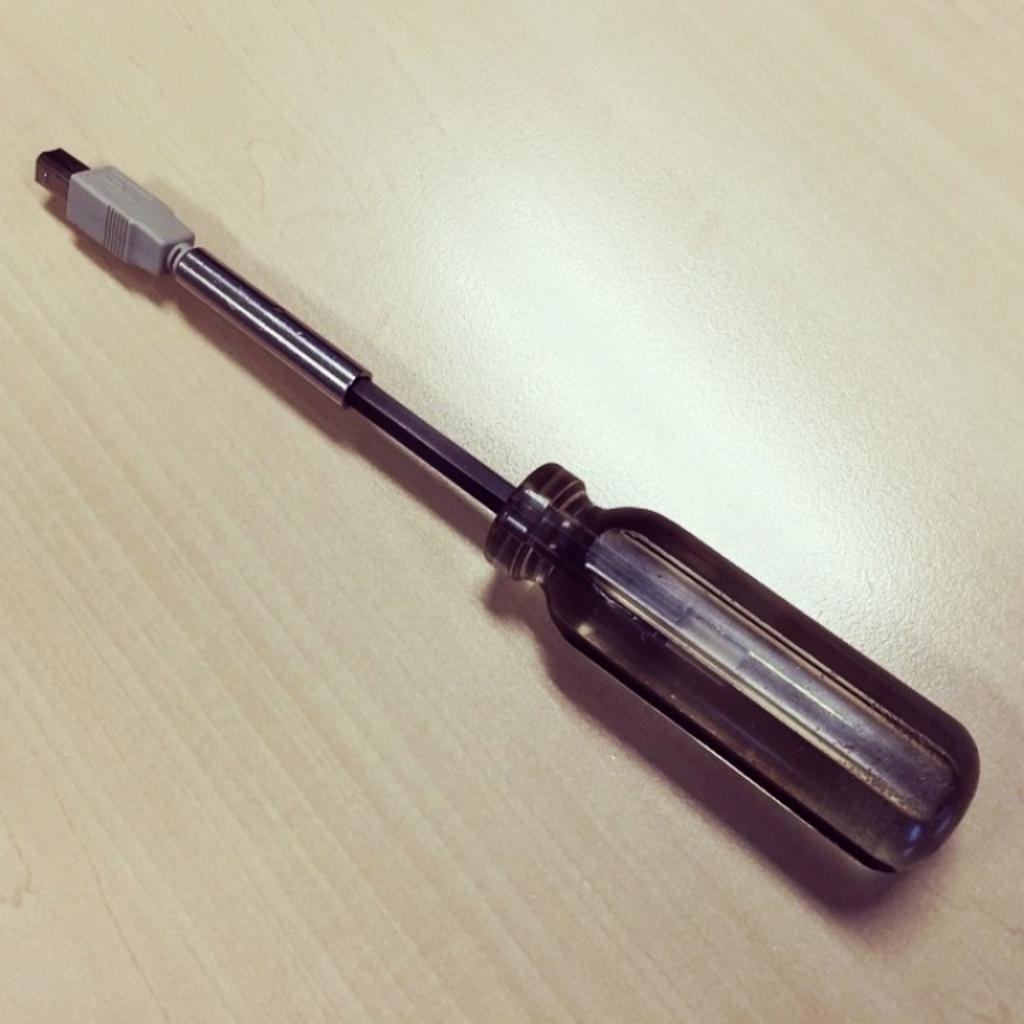What is the main object in the image? There is a turn screw in the image. On what surface is the turn screw placed? The turn screw is on a wooden table. What color is the background of the image? The background of the image is cream in color. Can you see any smoke coming from the turn screw in the image? There is no smoke present in the image; it features a turn screw on a wooden table with a cream-colored background. Is there a bed visible in the image? There is no bed present in the image; it only features a turn screw on a wooden table with a cream-colored background. 